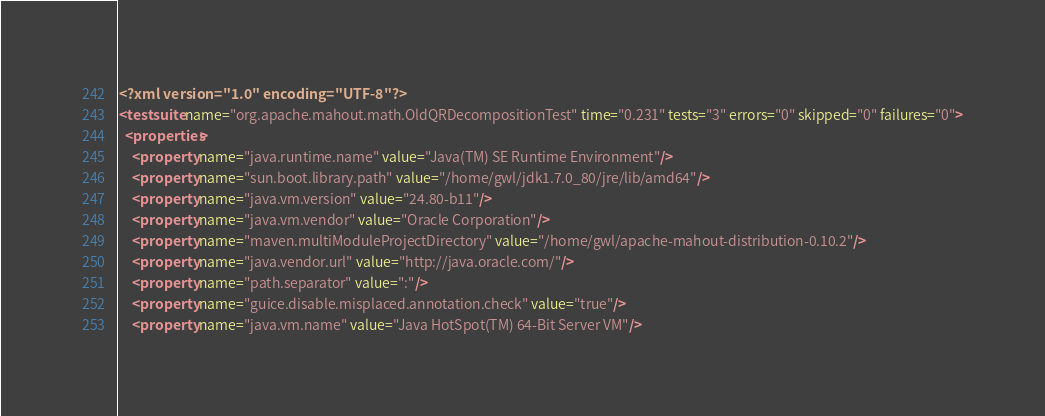<code> <loc_0><loc_0><loc_500><loc_500><_XML_><?xml version="1.0" encoding="UTF-8"?>
<testsuite name="org.apache.mahout.math.OldQRDecompositionTest" time="0.231" tests="3" errors="0" skipped="0" failures="0">
  <properties>
    <property name="java.runtime.name" value="Java(TM) SE Runtime Environment"/>
    <property name="sun.boot.library.path" value="/home/gwl/jdk1.7.0_80/jre/lib/amd64"/>
    <property name="java.vm.version" value="24.80-b11"/>
    <property name="java.vm.vendor" value="Oracle Corporation"/>
    <property name="maven.multiModuleProjectDirectory" value="/home/gwl/apache-mahout-distribution-0.10.2"/>
    <property name="java.vendor.url" value="http://java.oracle.com/"/>
    <property name="path.separator" value=":"/>
    <property name="guice.disable.misplaced.annotation.check" value="true"/>
    <property name="java.vm.name" value="Java HotSpot(TM) 64-Bit Server VM"/></code> 